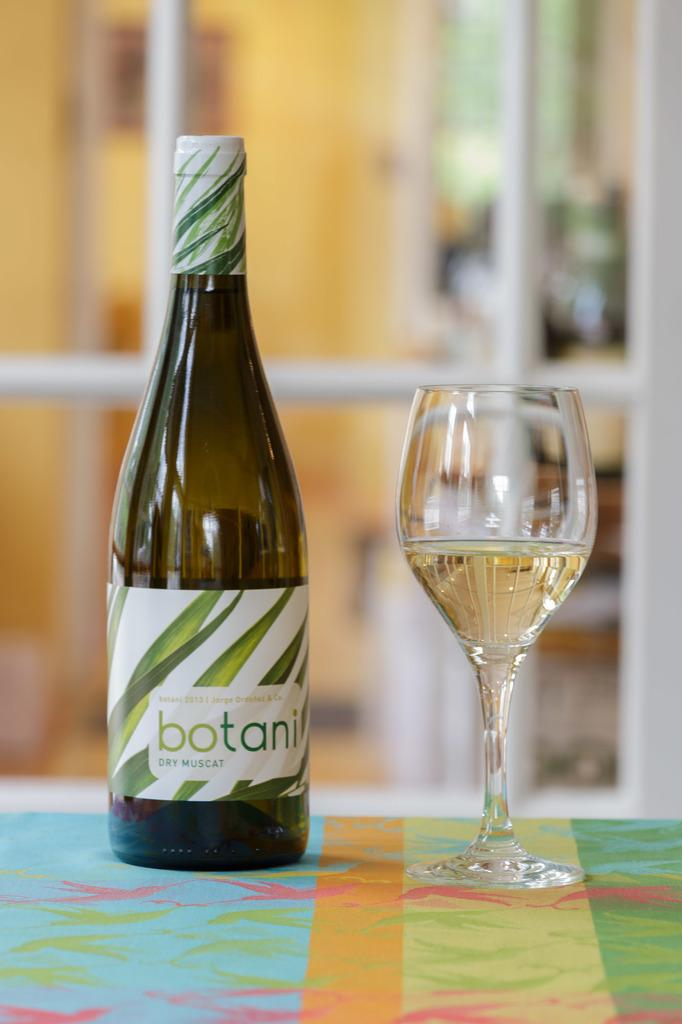What object is located on the left side of the image? There is a bottle on the left side of the image. What object is located on the right side of the image? There is a glass on the right side of the image. What is inside the glass in the image? The glass is filled with a drink. What type of army can be seen in the aftermath of the battle in the image? There is no army or battle present in the image; it only features a bottle and a glass filled with a drink. 